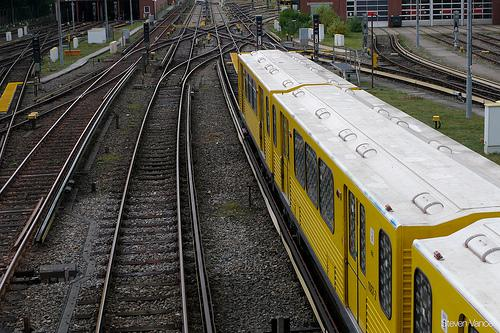Question: what is the color of the grass?
Choices:
A. Yellow.
B. Rusty.
C. Green.
D. White during winter.
Answer with the letter. Answer: C Question: what color are the tracks?
Choices:
A. Brown.
B. Black.
C. Silver.
D. White.
Answer with the letter. Answer: A Question: what color is the train?
Choices:
A. Yellow.
B. Silver.
C. White.
D. Gray.
Answer with the letter. Answer: A Question: where are the bushes?
Choices:
A. Forest.
B. In grass.
C. On a street.
D. In a park.
Answer with the letter. Answer: B Question: where is the train?
Choices:
A. On a bridge.
B. At the station.
C. On tracks.
D. Depot.
Answer with the letter. Answer: C 